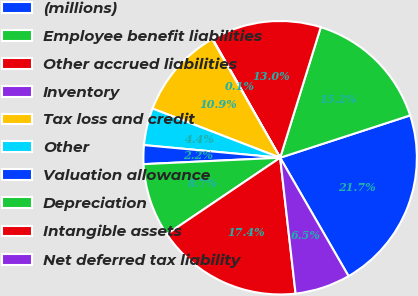Convert chart to OTSL. <chart><loc_0><loc_0><loc_500><loc_500><pie_chart><fcel>(millions)<fcel>Employee benefit liabilities<fcel>Other accrued liabilities<fcel>Inventory<fcel>Tax loss and credit<fcel>Other<fcel>Valuation allowance<fcel>Depreciation<fcel>Intangible assets<fcel>Net deferred tax liability<nl><fcel>21.67%<fcel>15.19%<fcel>13.03%<fcel>0.06%<fcel>10.86%<fcel>4.38%<fcel>2.22%<fcel>8.7%<fcel>17.35%<fcel>6.54%<nl></chart> 